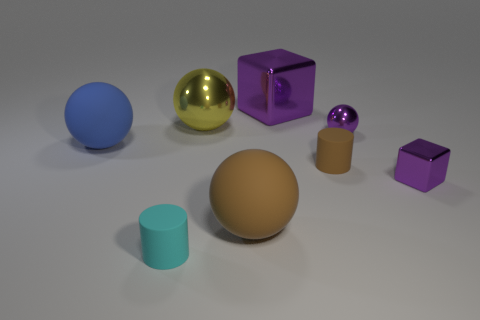Subtract 1 balls. How many balls are left? 3 Subtract all cubes. How many objects are left? 6 Add 1 brown rubber objects. How many objects exist? 9 Add 7 large rubber things. How many large rubber things are left? 9 Add 5 small green metallic cubes. How many small green metallic cubes exist? 5 Subtract 0 green balls. How many objects are left? 8 Subtract all tiny metallic blocks. Subtract all big brown matte spheres. How many objects are left? 6 